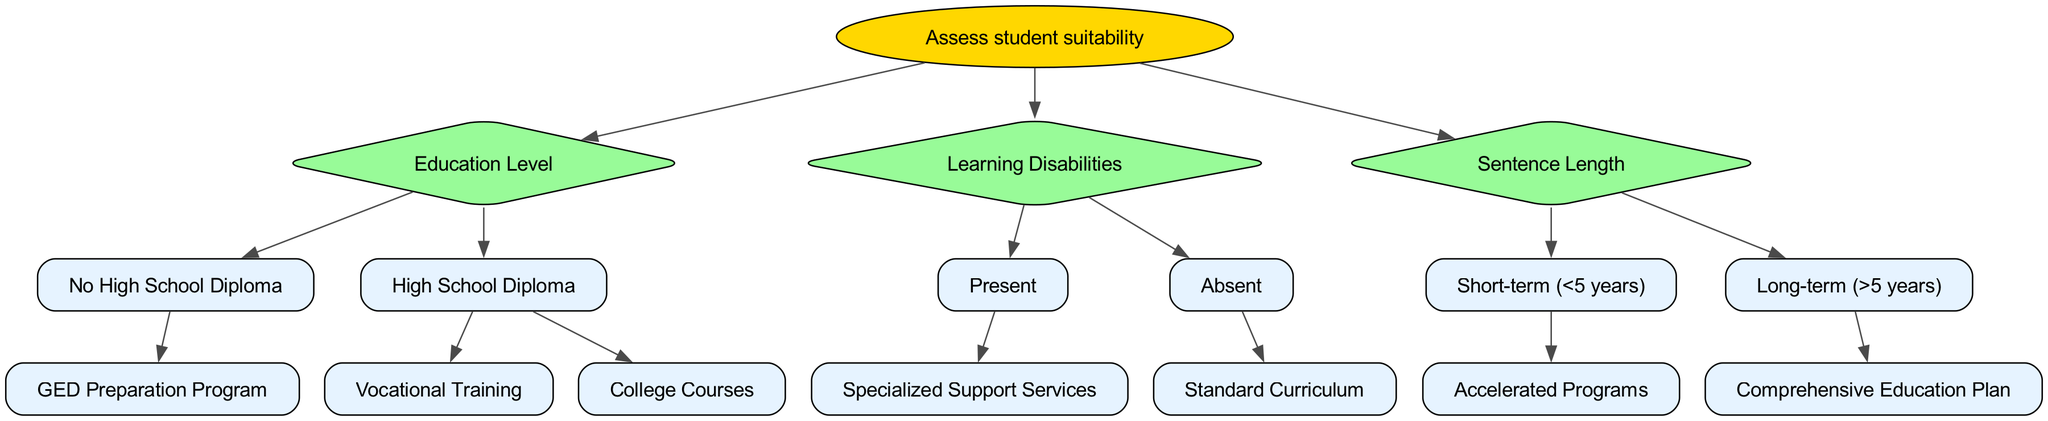What is the root of the decision tree? The root node of the decision tree is labeled "Assess student suitability", which is the starting point for all subsequent decisions regarding teaching methods and curricula.
Answer: Assess student suitability How many options are available for students with a High School Diploma? There are two options available for students with a High School Diploma, which are "Vocational Training" and "College Courses".
Answer: 2 What teaching method is recommended for students with no High School Diploma? Students without a High School Diploma are directed to the "GED Preparation Program", which is designed to help them obtain their GED certification.
Answer: GED Preparation Program What type of program is recommended for short-term sentence lengths? For those with a short-term sentence length of less than 5 years, the decision tree recommends "Accelerated Programs" to help them quickly gain skills or knowledge.
Answer: Accelerated Programs If a student has learning disabilities, what support is suggested? Students who have learning disabilities are directed towards "Specialized Support Services" to address their specific educational needs and enhance their learning experience.
Answer: Specialized Support Services What is the recommended education plan for long-term sentence lengths? For students with long-term sentence lengths greater than 5 years, the decision tree recommends a "Comprehensive Education Plan" to provide an in-depth and structured educational experience.
Answer: Comprehensive Education Plan How is the decision tree structured in terms of education level? The decision tree branches into two main categories based on education level: "No High School Diploma" and "High School Diploma," with specific programs associated with each category.
Answer: Two categories What type of node indicates a decision point in the tree? In the decision tree, diamond-shaped nodes indicate decision points where the flow of the diagram branches based on specific criteria or conditions related to the incarcerated students' suitability.
Answer: Diamond-shaped nodes How many children nodes does the "Learning Disabilities" node have? The "Learning Disabilities" node has two children nodes, corresponding to whether learning disabilities are present or absent.
Answer: 2 